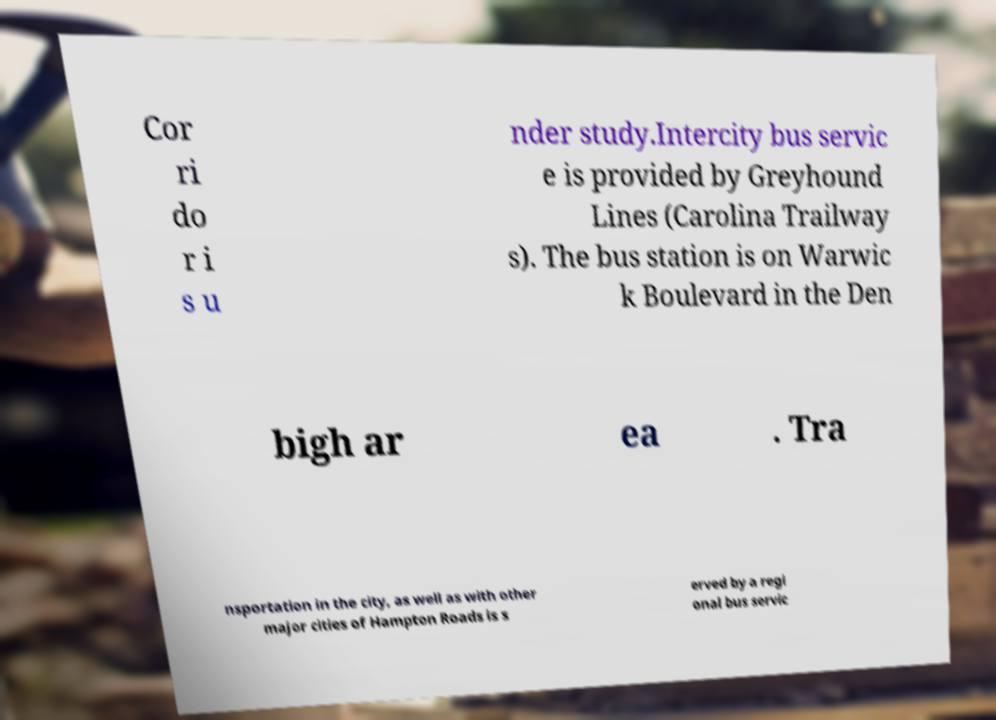Please identify and transcribe the text found in this image. Cor ri do r i s u nder study.Intercity bus servic e is provided by Greyhound Lines (Carolina Trailway s). The bus station is on Warwic k Boulevard in the Den bigh ar ea . Tra nsportation in the city, as well as with other major cities of Hampton Roads is s erved by a regi onal bus servic 